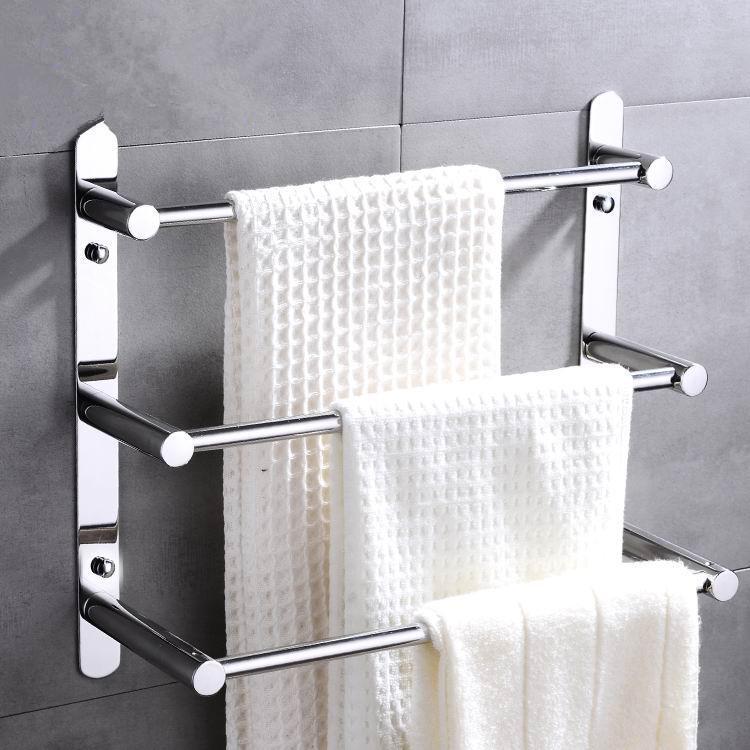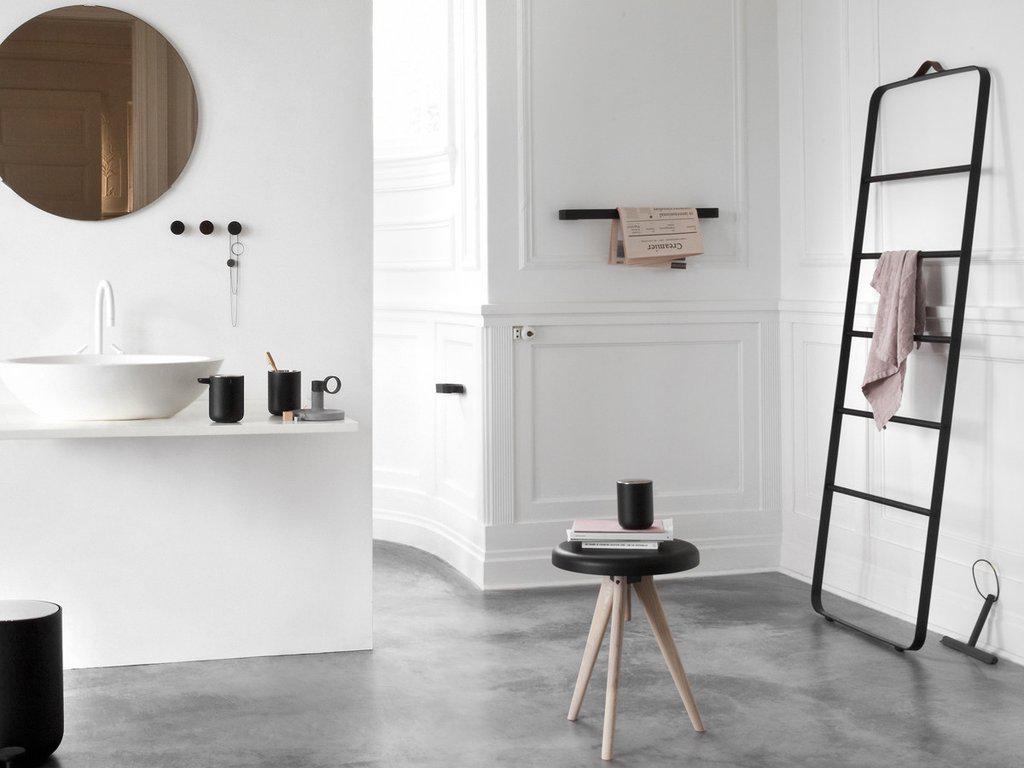The first image is the image on the left, the second image is the image on the right. For the images displayed, is the sentence "In one image, three white towels are arranged on a three-tiered chrome bathroom rack." factually correct? Answer yes or no. Yes. 